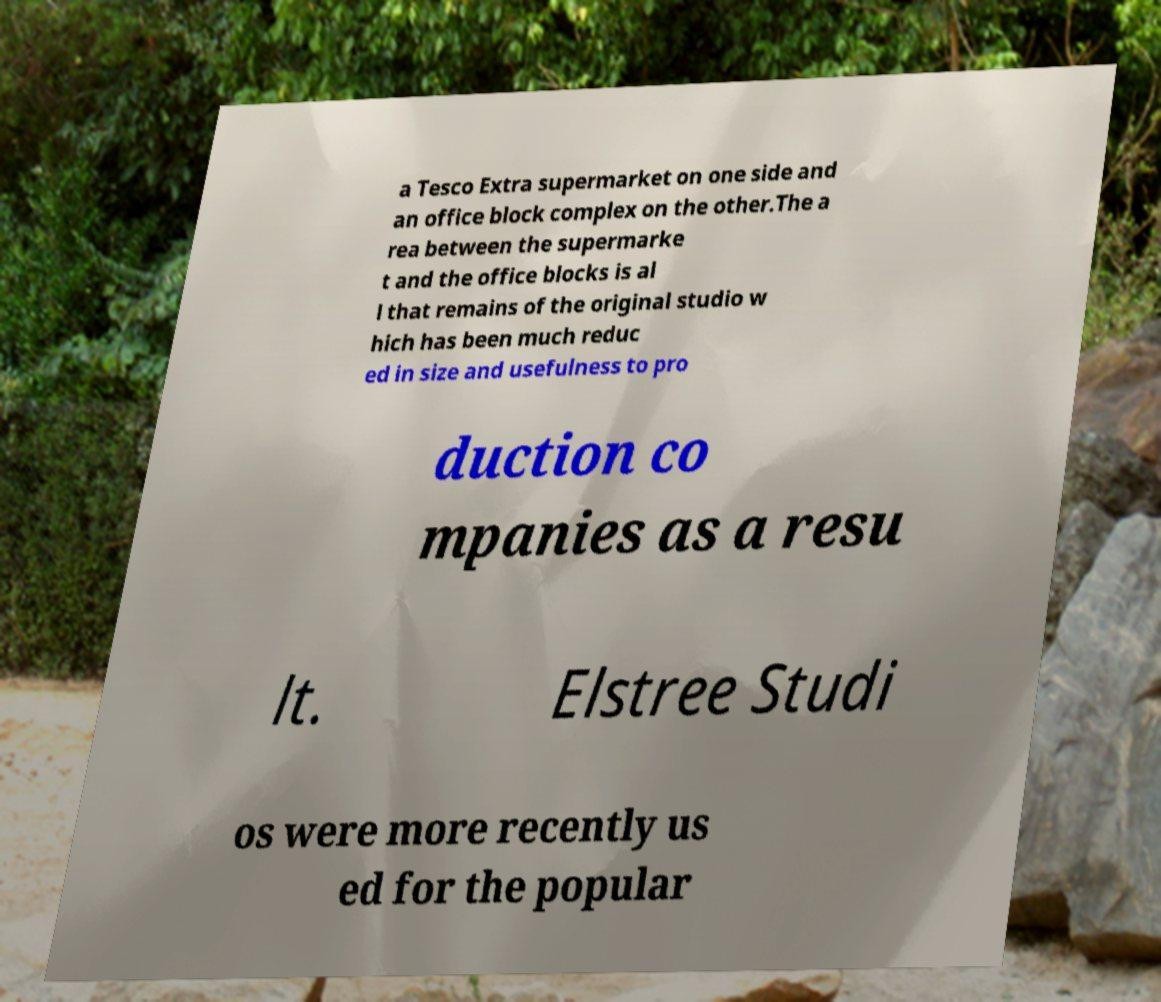I need the written content from this picture converted into text. Can you do that? a Tesco Extra supermarket on one side and an office block complex on the other.The a rea between the supermarke t and the office blocks is al l that remains of the original studio w hich has been much reduc ed in size and usefulness to pro duction co mpanies as a resu lt. Elstree Studi os were more recently us ed for the popular 